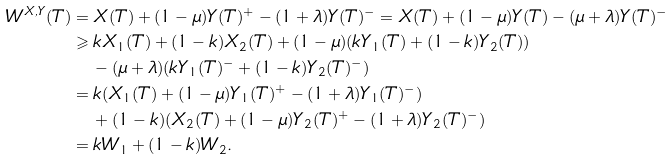<formula> <loc_0><loc_0><loc_500><loc_500>W ^ { X , Y } ( T ) & = X ( T ) + ( 1 - \mu ) Y ( T ) ^ { + } - ( 1 + \lambda ) Y ( T ) ^ { - } = X ( T ) + ( 1 - \mu ) Y ( T ) - ( \mu + \lambda ) Y ( T ) ^ { - } \\ & \geqslant k X _ { 1 } ( T ) + ( 1 - k ) X _ { 2 } ( T ) + ( 1 - \mu ) ( k Y _ { 1 } ( T ) + ( 1 - k ) Y _ { 2 } ( T ) ) \\ & \quad - ( \mu + \lambda ) ( k Y _ { 1 } ( T ) ^ { - } + ( 1 - k ) Y _ { 2 } ( T ) ^ { - } ) \\ & = k ( X _ { 1 } ( T ) + ( 1 - \mu ) Y _ { 1 } ( T ) ^ { + } - ( 1 + \lambda ) Y _ { 1 } ( T ) ^ { - } ) \\ & \quad + ( 1 - k ) ( X _ { 2 } ( T ) + ( 1 - \mu ) Y _ { 2 } ( T ) ^ { + } - ( 1 + \lambda ) Y _ { 2 } ( T ) ^ { - } ) \\ & = k W _ { 1 } + ( 1 - k ) W _ { 2 } .</formula> 